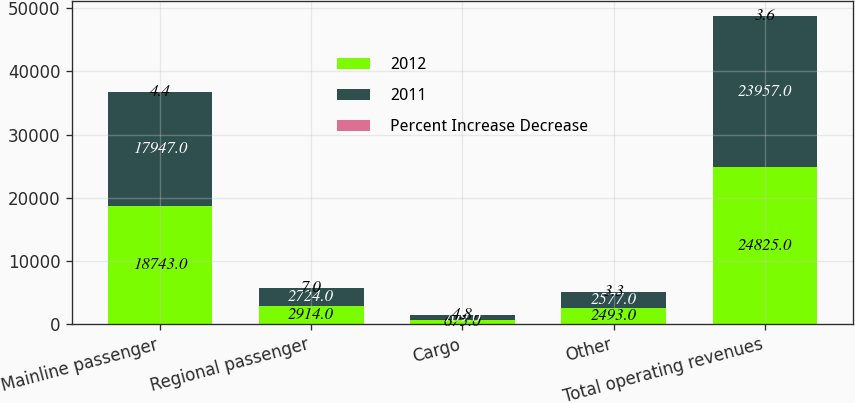Convert chart to OTSL. <chart><loc_0><loc_0><loc_500><loc_500><stacked_bar_chart><ecel><fcel>Mainline passenger<fcel>Regional passenger<fcel>Cargo<fcel>Other<fcel>Total operating revenues<nl><fcel>2012<fcel>18743<fcel>2914<fcel>675<fcel>2493<fcel>24825<nl><fcel>2011<fcel>17947<fcel>2724<fcel>709<fcel>2577<fcel>23957<nl><fcel>Percent Increase Decrease<fcel>4.4<fcel>7<fcel>4.8<fcel>3.3<fcel>3.6<nl></chart> 